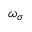Convert formula to latex. <formula><loc_0><loc_0><loc_500><loc_500>\omega _ { \sigma }</formula> 